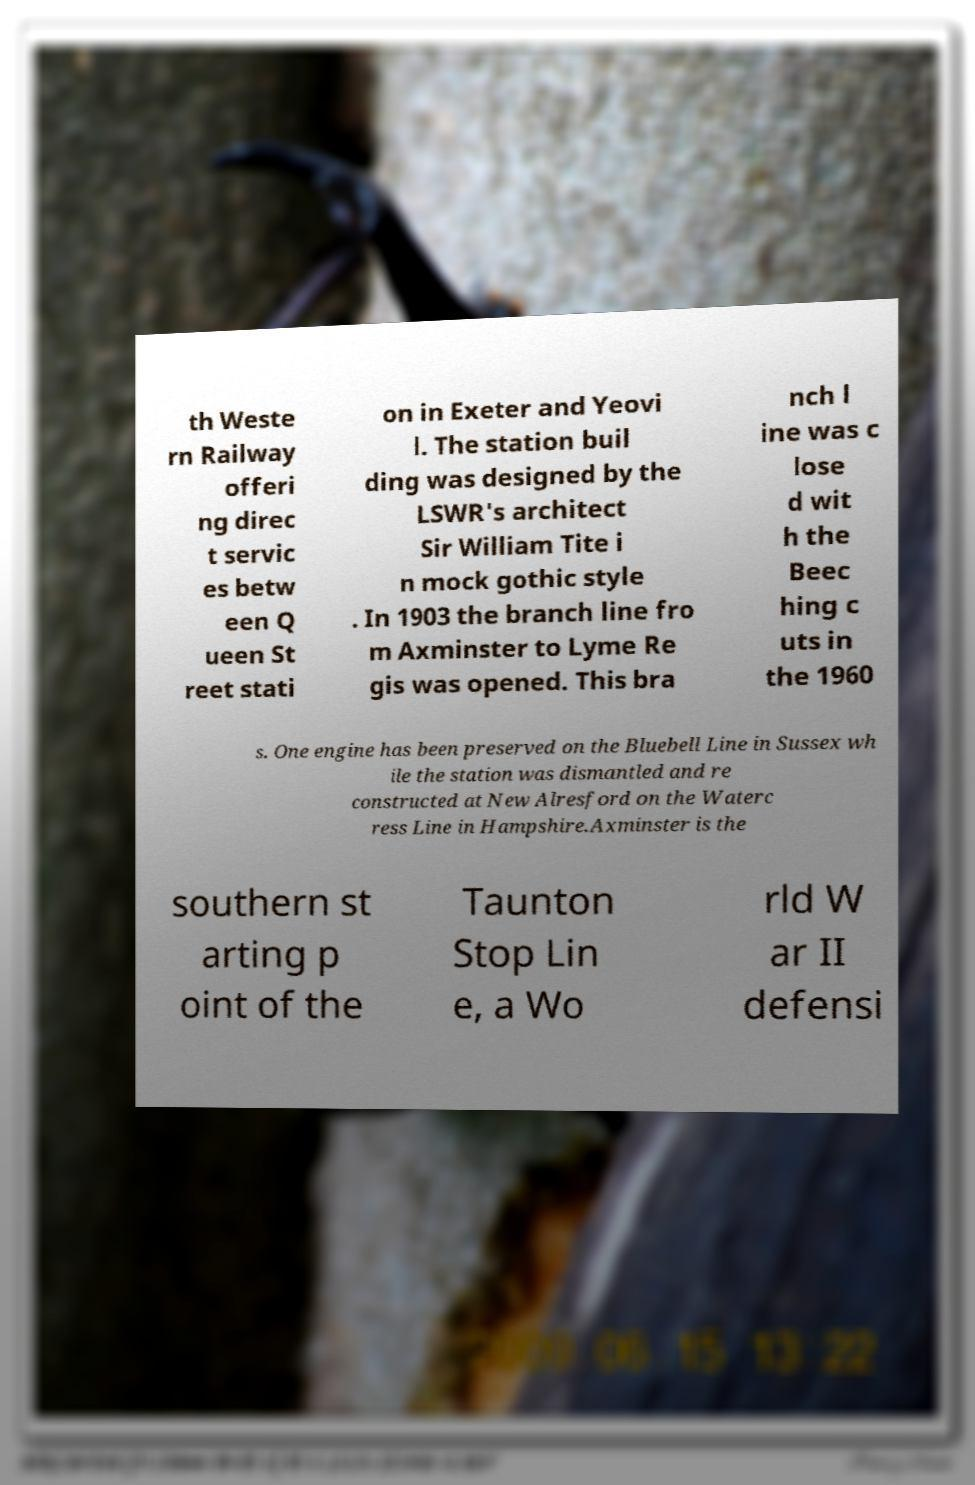Please identify and transcribe the text found in this image. th Weste rn Railway offeri ng direc t servic es betw een Q ueen St reet stati on in Exeter and Yeovi l. The station buil ding was designed by the LSWR's architect Sir William Tite i n mock gothic style . In 1903 the branch line fro m Axminster to Lyme Re gis was opened. This bra nch l ine was c lose d wit h the Beec hing c uts in the 1960 s. One engine has been preserved on the Bluebell Line in Sussex wh ile the station was dismantled and re constructed at New Alresford on the Waterc ress Line in Hampshire.Axminster is the southern st arting p oint of the Taunton Stop Lin e, a Wo rld W ar II defensi 